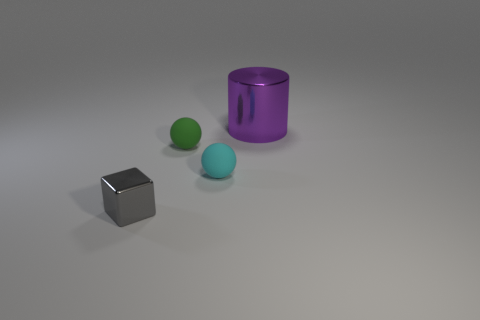Add 4 tiny red metallic cylinders. How many objects exist? 8 Subtract all cylinders. How many objects are left? 3 Subtract all big things. Subtract all spheres. How many objects are left? 1 Add 2 cyan spheres. How many cyan spheres are left? 3 Add 3 small matte objects. How many small matte objects exist? 5 Subtract 1 purple cylinders. How many objects are left? 3 